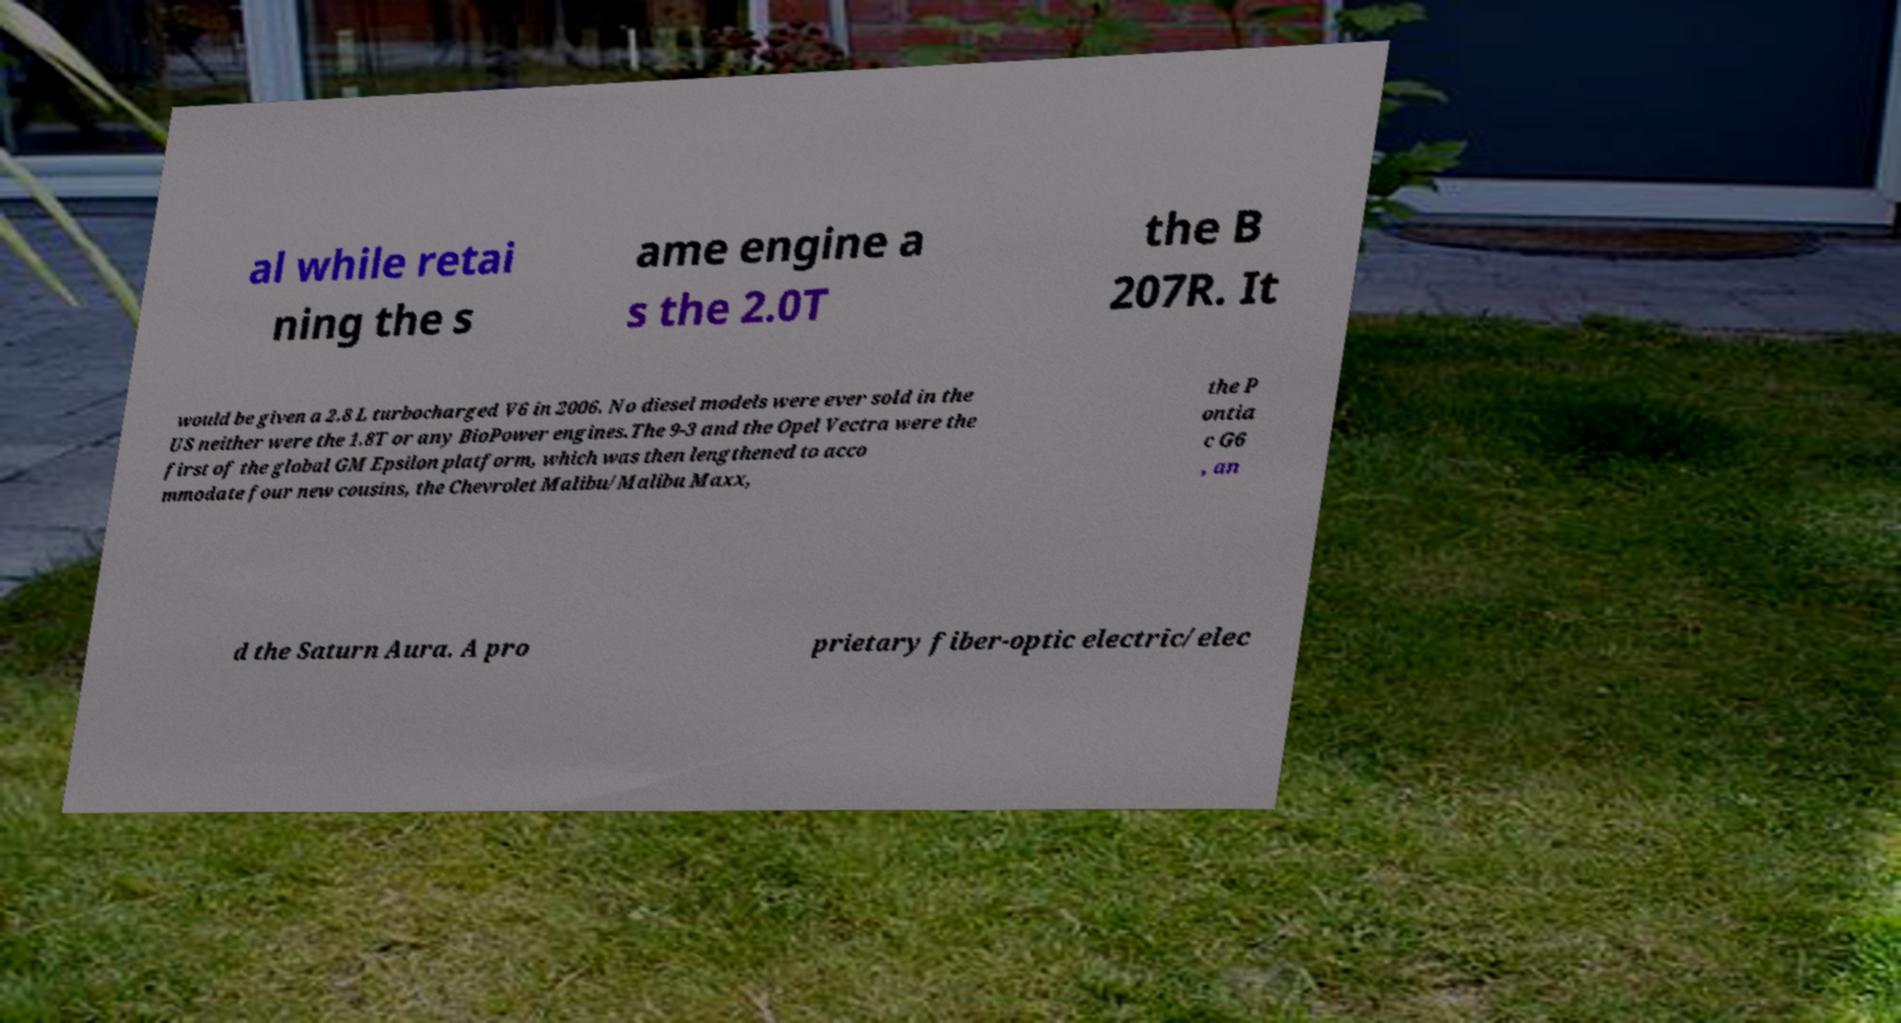For documentation purposes, I need the text within this image transcribed. Could you provide that? al while retai ning the s ame engine a s the 2.0T the B 207R. It would be given a 2.8 L turbocharged V6 in 2006. No diesel models were ever sold in the US neither were the 1.8T or any BioPower engines.The 9-3 and the Opel Vectra were the first of the global GM Epsilon platform, which was then lengthened to acco mmodate four new cousins, the Chevrolet Malibu/Malibu Maxx, the P ontia c G6 , an d the Saturn Aura. A pro prietary fiber-optic electric/elec 